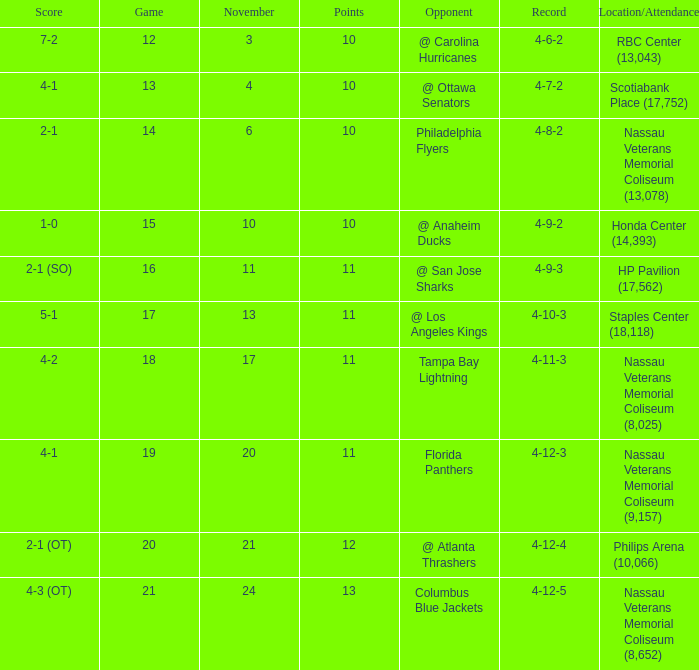What is every game on November 21? 20.0. 